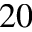Convert formula to latex. <formula><loc_0><loc_0><loc_500><loc_500>2 0</formula> 